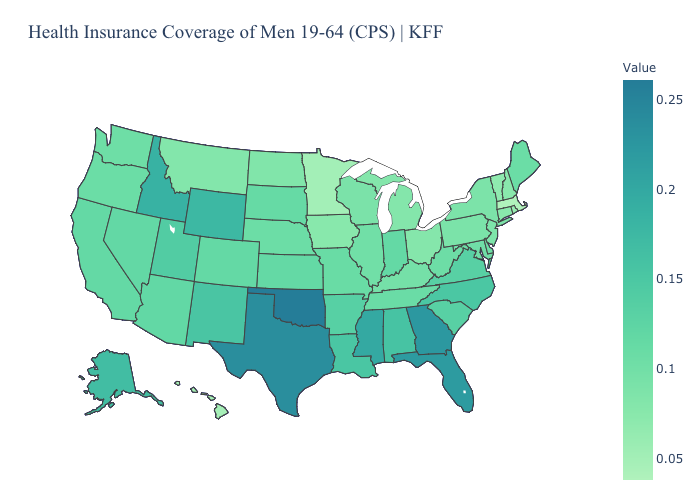Which states hav the highest value in the MidWest?
Give a very brief answer. Indiana, Kansas. Which states have the lowest value in the South?
Short answer required. Kentucky. Which states hav the highest value in the West?
Short answer required. Idaho. Does New York have the highest value in the Northeast?
Answer briefly. No. 